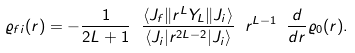<formula> <loc_0><loc_0><loc_500><loc_500>\varrho _ { f i } ( r ) = - \frac { 1 } { 2 L + 1 } \ \frac { \langle J _ { f } \| r ^ { L } Y _ { L } \| J _ { i } \rangle } { \langle J _ { i } | r ^ { 2 L - 2 } | J _ { i } \rangle } \ r ^ { L - 1 } \ \frac { d } { d r } \varrho _ { 0 } ( r ) .</formula> 